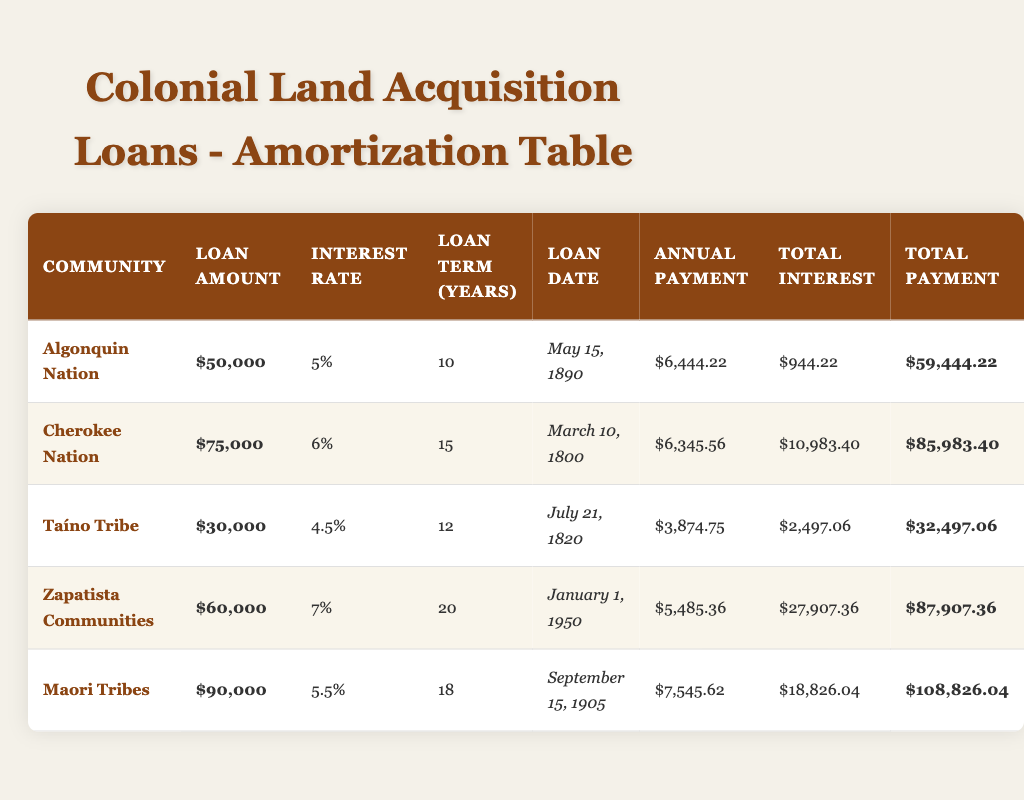What is the loan amount for the Algonquin Nation? The table lists the loan amount for the Algonquin Nation as $50,000. This can be found in the "Loan Amount" column corresponding to the row for the Algonquin Nation.
Answer: $50,000 How much total interest did the Maori Tribes pay on their loan? According to the table, the total interest paid by the Maori Tribes is $18,826.04, which is directly available in the "Total Interest" column in the row for the Maori Tribes.
Answer: $18,826.04 What is the average annual payment across all communities? To find the average, we need to sum the annual payments for all communities: (6444.22 + 6345.56 + 3874.75 + 5485.36 + 7545.62) = 30795.51. There are 5 communities, so the average is 30795.51 / 5 = 6159.10.
Answer: $6,159.10 Did the Zapatista Communities have a higher loan term than the Taíno Tribe? The loan term for Zapatista Communities is 20 years, while the loan term for Taíno Tribe is 12 years. Thus, the statement is true as 20 years is greater than 12 years.
Answer: Yes What is the total payment for the Cherokee Nation? In the table, the total payment for the Cherokee Nation is $85,983.40. This is found in the "Total Payment" column in the row for the Cherokee Nation.
Answer: $85,983.40 Which community had the highest interest rate, and what was it? Reviewing the interest rates in the table shows that the Zapatista Communities had the highest interest rate at 7%. This can be confirmed by directly comparing the values in the "Interest Rate" column.
Answer: Zapatista Communities, 7% What is the total amount paid by the Taíno Tribe including interest? The total payment, including interest, for the Taíno Tribe is $32,497.06, which is provided directly in the "Total Payment" column for that community in the table.
Answer: $32,497.06 How many years did the Algonquin Nation take to repay their loan? The table specifies the loan term for the Algonquin Nation as 10 years, detailed in the column labeled "Loan Term."
Answer: 10 years Is the total interest paid by the Zapatista Communities less than that paid by the Maori Tribes? The total interest paid by Zapatista Communities is $27,907.36, while the total interest paid by Maori Tribes is $18,826.04. Since $27,907.36 is greater than $18,826.04, the statement is false.
Answer: No 